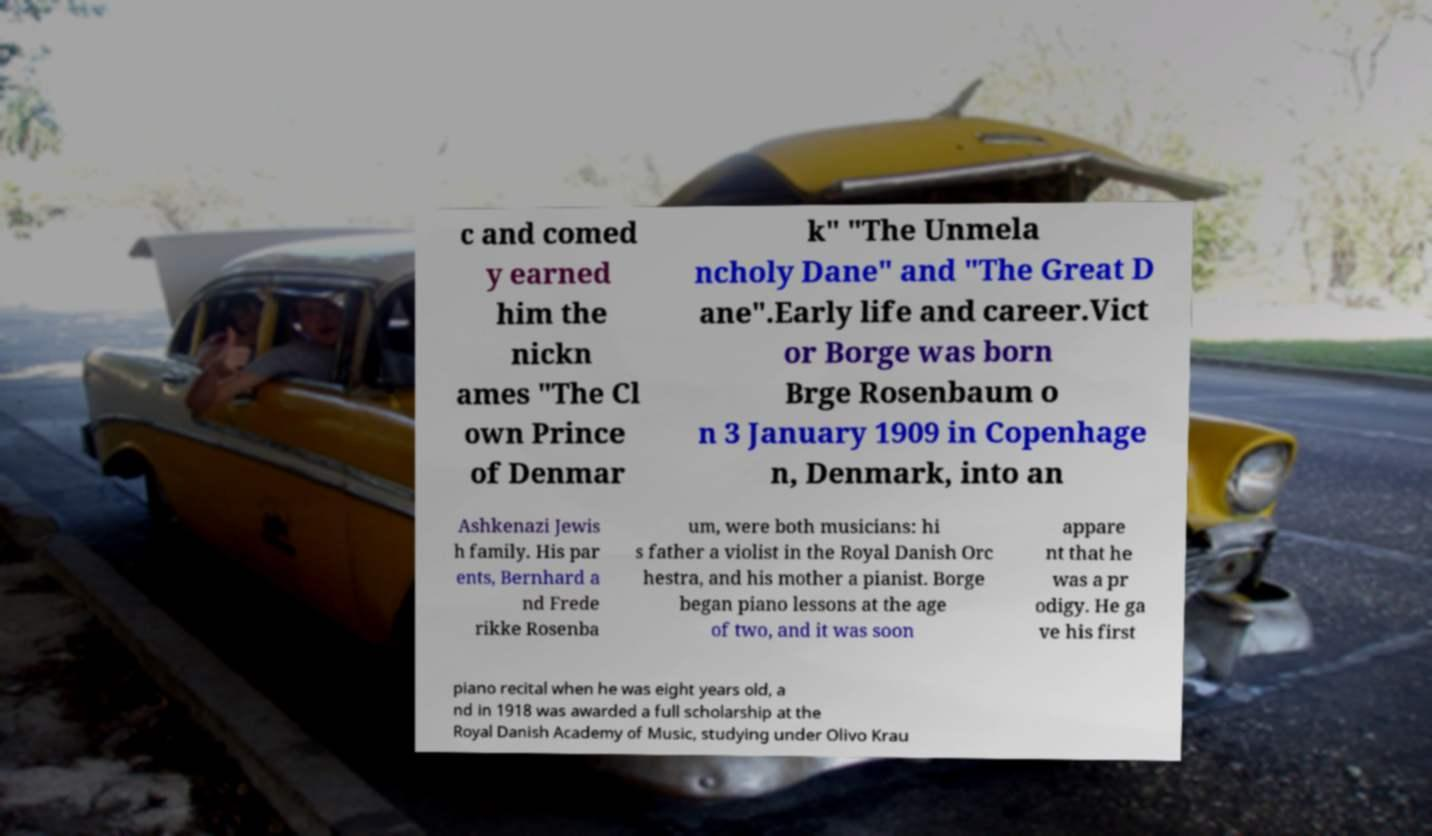Can you accurately transcribe the text from the provided image for me? c and comed y earned him the nickn ames "The Cl own Prince of Denmar k" "The Unmela ncholy Dane" and "The Great D ane".Early life and career.Vict or Borge was born Brge Rosenbaum o n 3 January 1909 in Copenhage n, Denmark, into an Ashkenazi Jewis h family. His par ents, Bernhard a nd Frede rikke Rosenba um, were both musicians: hi s father a violist in the Royal Danish Orc hestra, and his mother a pianist. Borge began piano lessons at the age of two, and it was soon appare nt that he was a pr odigy. He ga ve his first piano recital when he was eight years old, a nd in 1918 was awarded a full scholarship at the Royal Danish Academy of Music, studying under Olivo Krau 